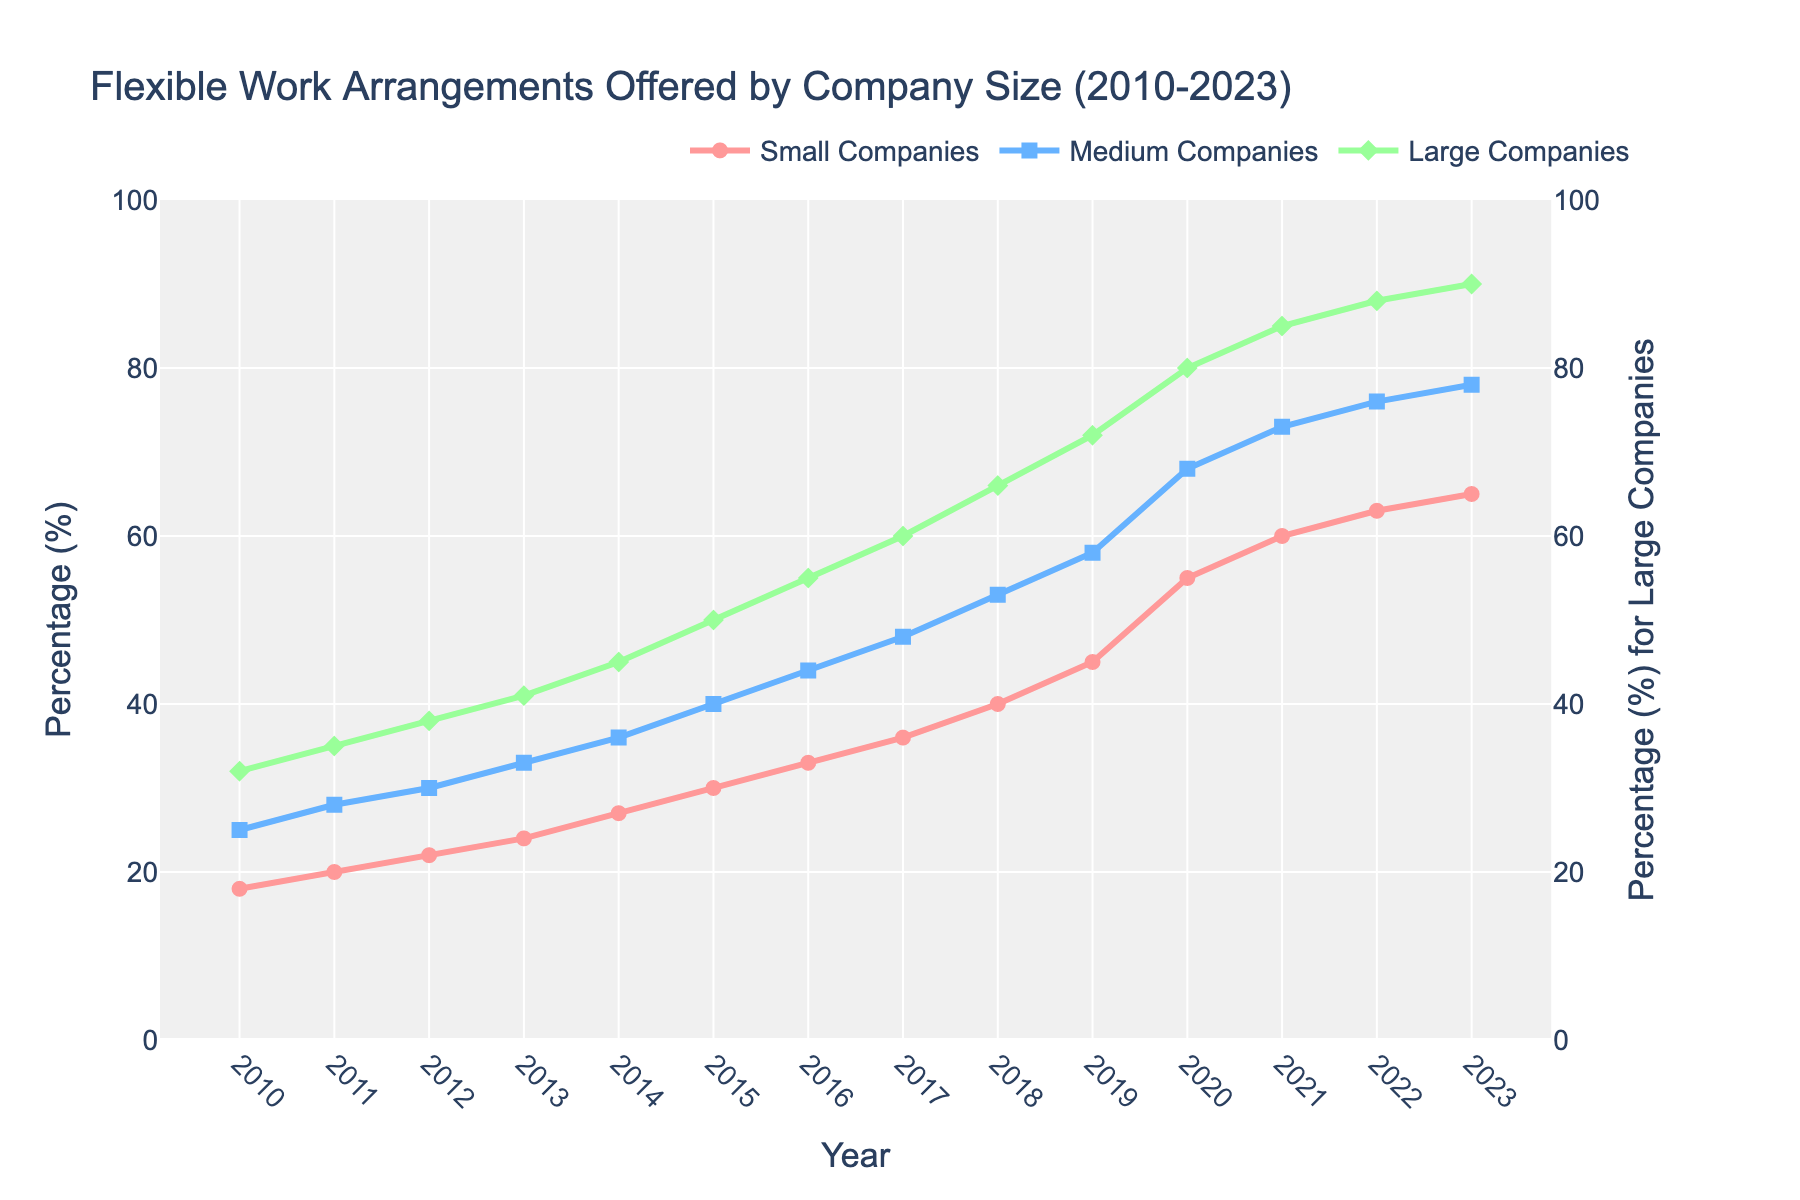What's the trend in the percentage of small companies (1-49 employees) offering flexible work arrangements from 2010 to 2023? To find the trend, look at the line for small companies (indicated by red circles) and observe the overall direction over time. The line shows a steady increase from 18% in 2010 to 65% in 2023.
Answer: A steady increase Which year shows the biggest increase in the percentage of large companies (250+ employees) offering flexible work arrangements compared to the previous year? Examine the green diamond markers for large companies and check the differences year by year. The largest leap is between 2019 and 2020, where the percentage jumps from 72% to 80%.
Answer: 2020 How do the percentages of medium companies (50-249 employees) and large companies (250+ employees) offering flexible work arrangements compare in 2023? Look at the final values in 2023 for both medium (blue squares) and large companies (green diamonds). The percentage for medium companies is 78%, while for large companies it is 90%.
Answer: Large companies have a higher percentage What is the average percentage of small companies (1-49 employees) offering flexible work arrangements in the years 2020, 2021, and 2022? Sum the values for these years and divide by 3. (55% + 60% + 63%) / 3 = 178% / 3 = 59.33%.
Answer: 59.33% Compare the growth in percentage of flexible work arrangements for small companies (1-49 employees) from 2010 to 2023 versus medium companies (50-249 employees) in the same period. Compute the difference between 2023 and 2010 for both small and medium companies: Small: 65% - 18% = 47%; Medium: 78% - 25% = 53%.
Answer: Medium companies have a higher growth (53% vs 47%) What's the difference in the percentage of large companies (250+ employees) offering flexible work arrangements between 2016 and 2023? Subtract the percentage for large companies in 2016 from the percentage in 2023. 90% - 55% = 35%.
Answer: 35% difference In which year did medium companies (50-249 employees) surpass 50% in offering flexible work arrangements, and by how much? Check the blue line for medium companies and find when it first goes above 50%. This occurs in 2018, where the percentage is 53%.
Answer: 2018, surpassed by 3% How does the percentage increase in flexible work arrangements between 2010 and 2015 compare across all company sizes (small, medium, and large)? Calculate the differences for each company size between 2010 and 2015: Small: 30% - 18% = 12%; Medium: 40% - 25% = 15%; Large: 50% - 32% = 18%.
Answer: Large companies had the largest increase Which year did all company sizes' percentages show an increase compared to the previous year? Look for a year in which all trend lines (red, blue, and green) exhibit an upward movement from the previous year. From 2011 to 2023, every year has an increase for all company sizes.
Answer: All years from 2011 to 2023 